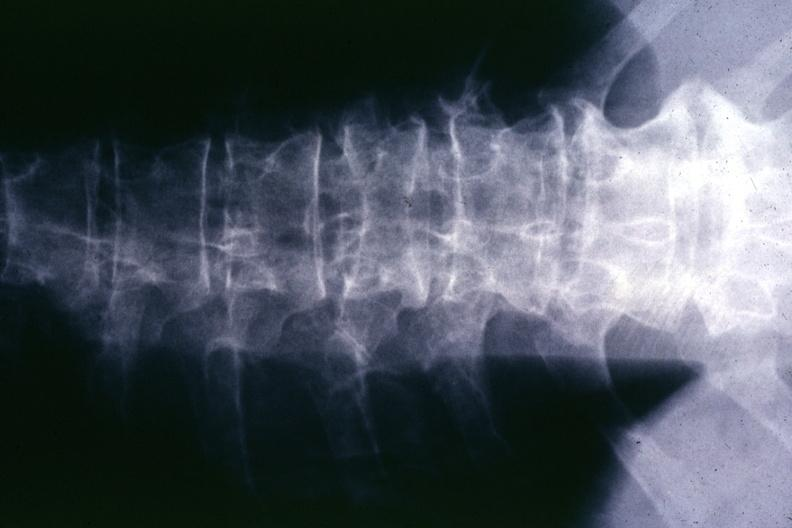s joints present?
Answer the question using a single word or phrase. Yes 